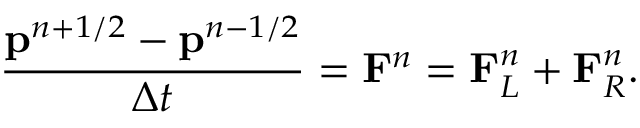Convert formula to latex. <formula><loc_0><loc_0><loc_500><loc_500>\frac { p ^ { n + 1 / 2 } - p ^ { n - 1 / 2 } } { \Delta t } = F ^ { n } = F _ { L } ^ { n } + F _ { R } ^ { n } .</formula> 